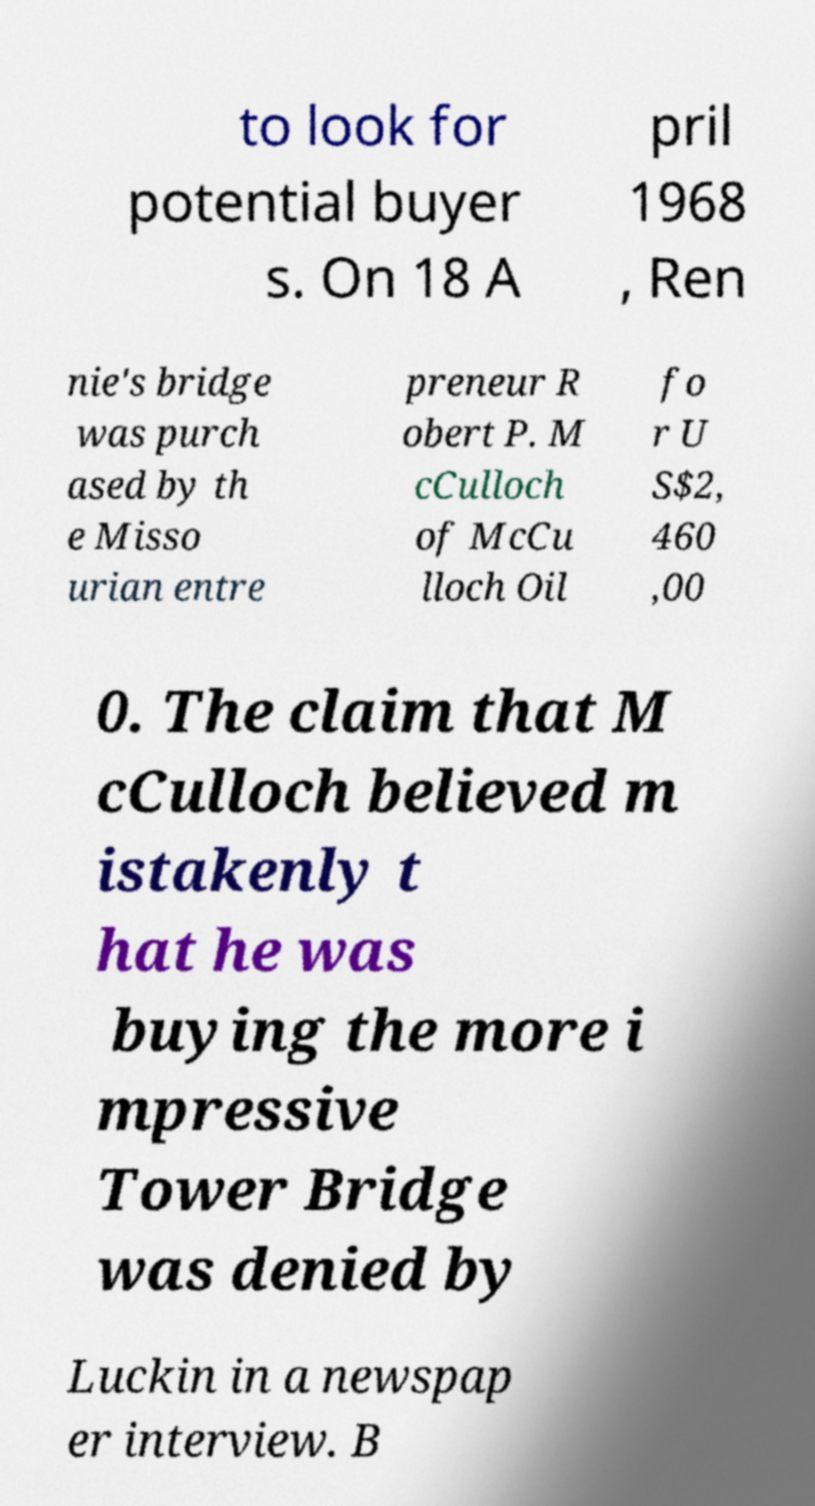Could you assist in decoding the text presented in this image and type it out clearly? to look for potential buyer s. On 18 A pril 1968 , Ren nie's bridge was purch ased by th e Misso urian entre preneur R obert P. M cCulloch of McCu lloch Oil fo r U S$2, 460 ,00 0. The claim that M cCulloch believed m istakenly t hat he was buying the more i mpressive Tower Bridge was denied by Luckin in a newspap er interview. B 